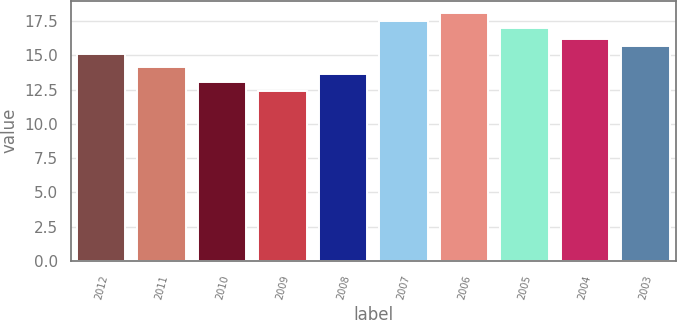Convert chart to OTSL. <chart><loc_0><loc_0><loc_500><loc_500><bar_chart><fcel>2012<fcel>2011<fcel>2010<fcel>2009<fcel>2008<fcel>2007<fcel>2006<fcel>2005<fcel>2004<fcel>2003<nl><fcel>15.1<fcel>14.18<fcel>13.06<fcel>12.44<fcel>13.62<fcel>17.54<fcel>18.1<fcel>16.98<fcel>16.22<fcel>15.66<nl></chart> 